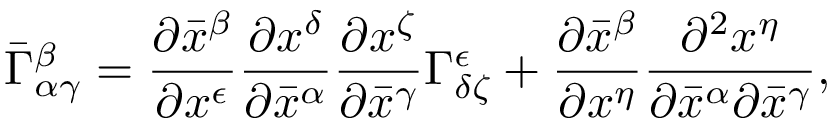Convert formula to latex. <formula><loc_0><loc_0><loc_500><loc_500>{ \bar { \Gamma } } _ { \alpha \gamma } ^ { \beta } = { \frac { \partial { \bar { x } } ^ { \beta } } { \partial x ^ { \epsilon } } } { \frac { \partial x ^ { \delta } } { \partial { \bar { x } } ^ { \alpha } } } { \frac { \partial x ^ { \zeta } } { \partial { \bar { x } } ^ { \gamma } } } \Gamma _ { \delta \zeta } ^ { \epsilon } + { \frac { \partial { \bar { x } } ^ { \beta } } { \partial x ^ { \eta } } } { \frac { \partial ^ { 2 } x ^ { \eta } } { \partial { \bar { x } } ^ { \alpha } \partial { \bar { x } } ^ { \gamma } } } ,</formula> 